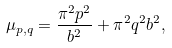<formula> <loc_0><loc_0><loc_500><loc_500>\mu _ { p , q } = \frac { \pi ^ { 2 } p ^ { 2 } } { b ^ { 2 } } + \pi ^ { 2 } q ^ { 2 } b ^ { 2 } ,</formula> 